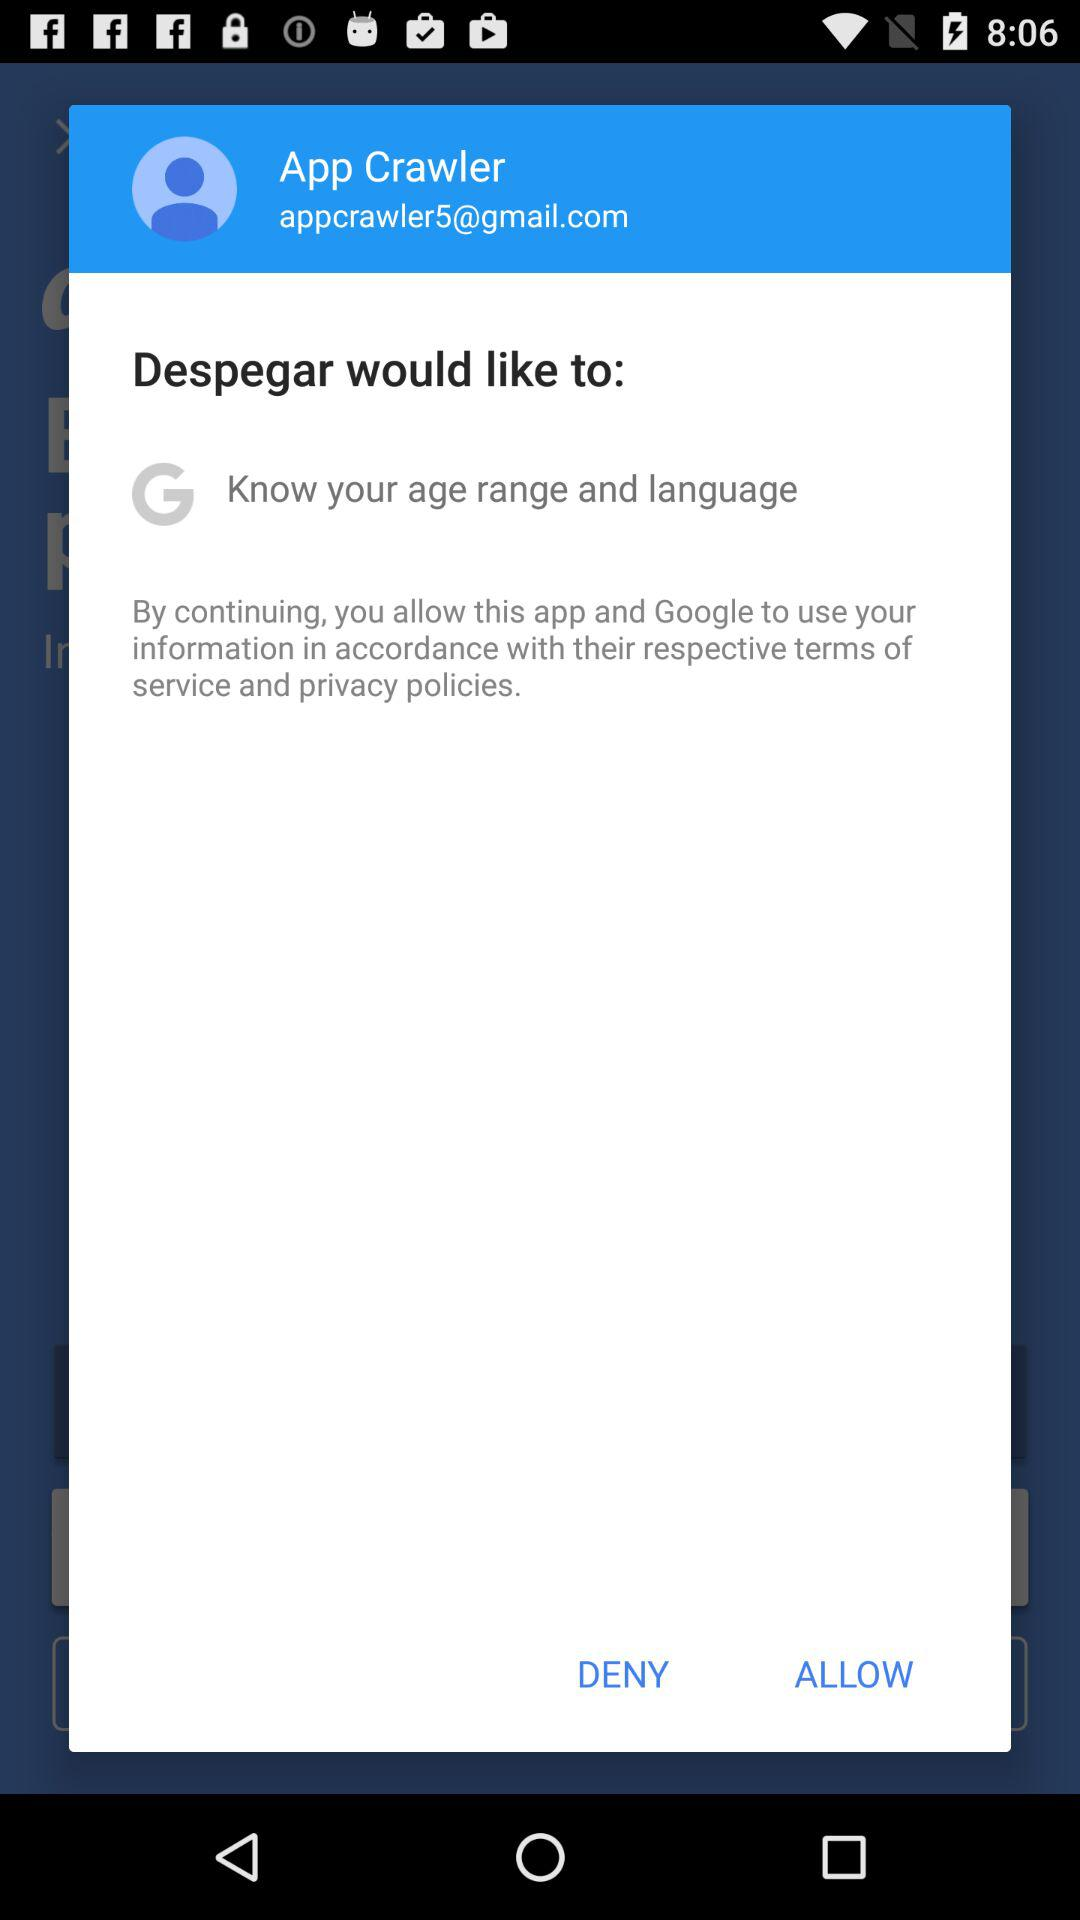What is the user name? The user name is App Crawler. 